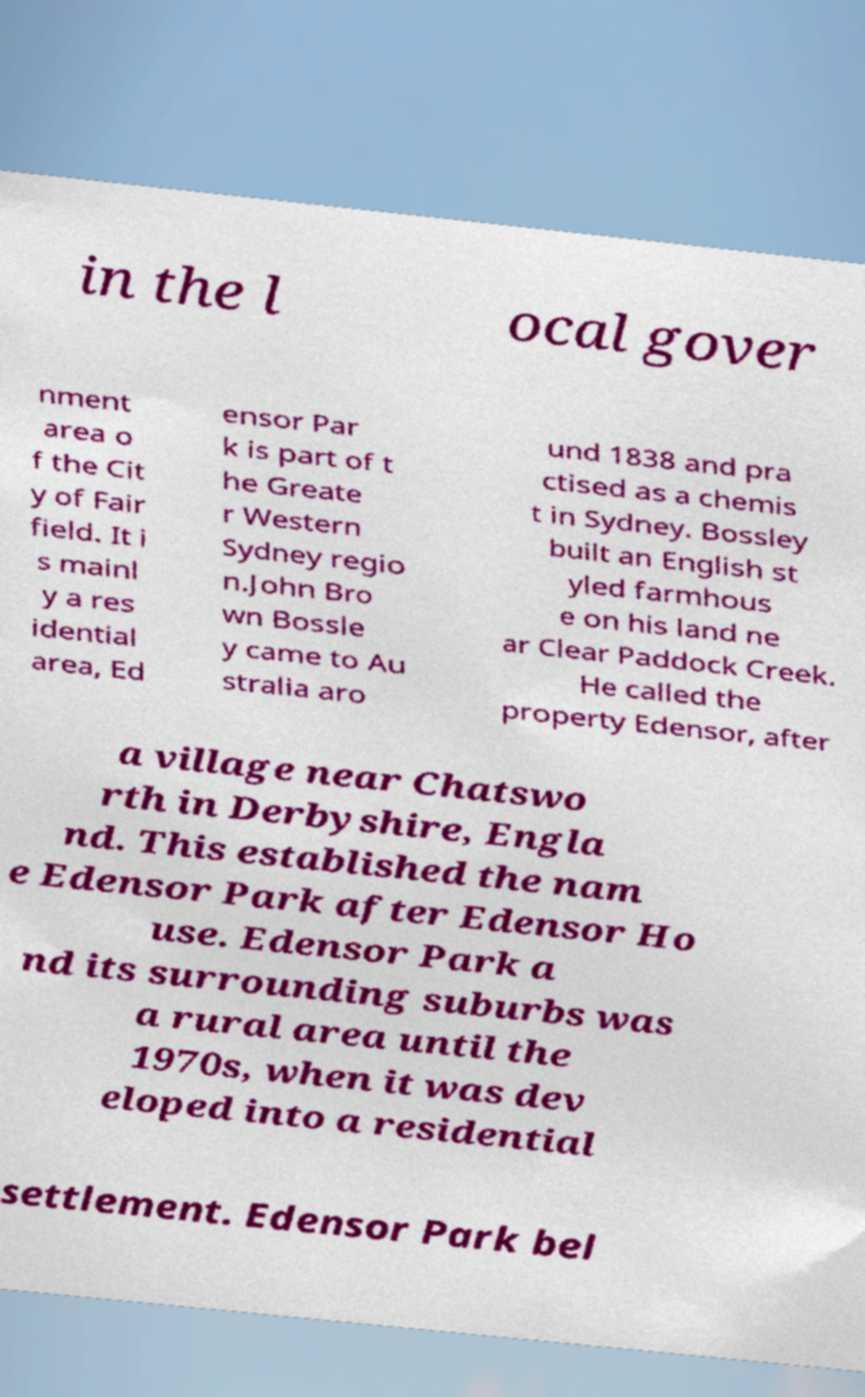Please identify and transcribe the text found in this image. in the l ocal gover nment area o f the Cit y of Fair field. It i s mainl y a res idential area, Ed ensor Par k is part of t he Greate r Western Sydney regio n.John Bro wn Bossle y came to Au stralia aro und 1838 and pra ctised as a chemis t in Sydney. Bossley built an English st yled farmhous e on his land ne ar Clear Paddock Creek. He called the property Edensor, after a village near Chatswo rth in Derbyshire, Engla nd. This established the nam e Edensor Park after Edensor Ho use. Edensor Park a nd its surrounding suburbs was a rural area until the 1970s, when it was dev eloped into a residential settlement. Edensor Park bel 